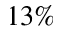Convert formula to latex. <formula><loc_0><loc_0><loc_500><loc_500>1 3 \%</formula> 